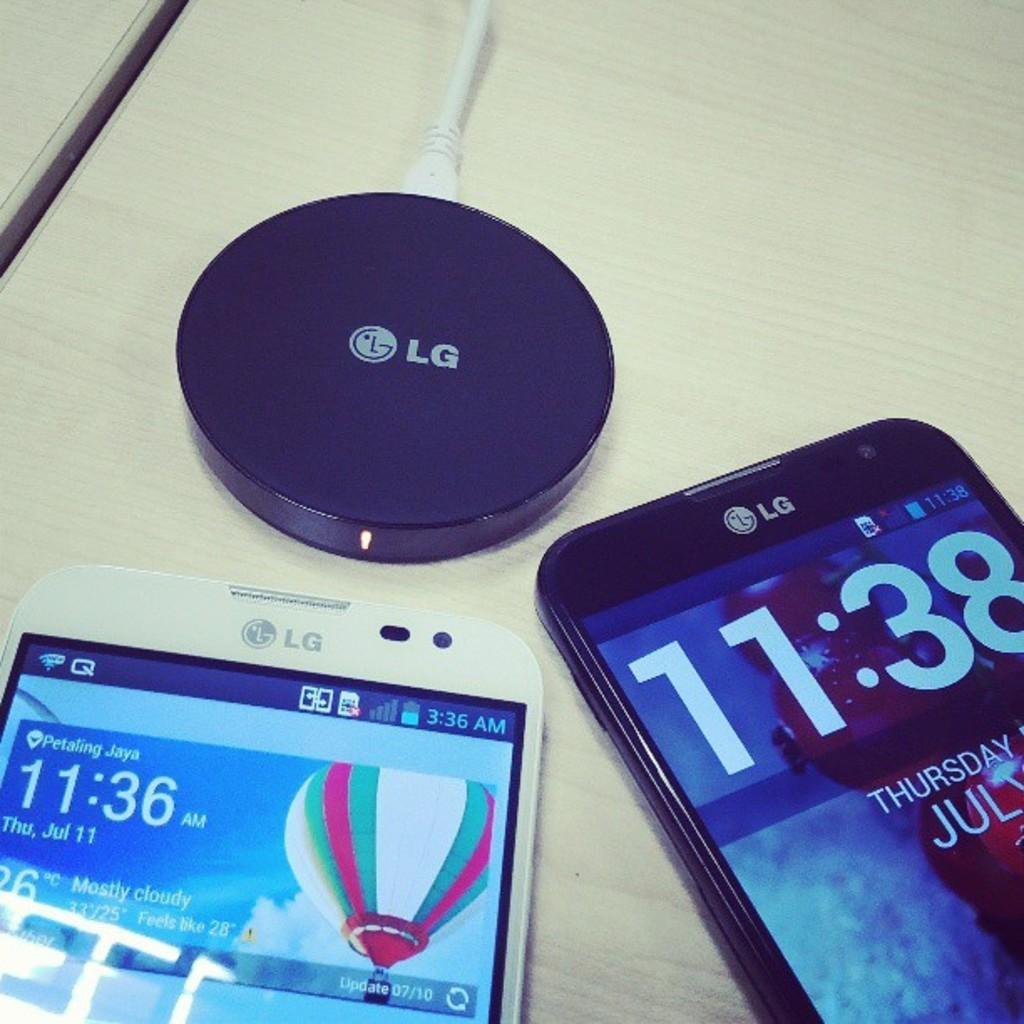Provide a one-sentence caption for the provided image. Two phones on a table next to an LG Battery. 